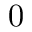Convert formula to latex. <formula><loc_0><loc_0><loc_500><loc_500>0</formula> 